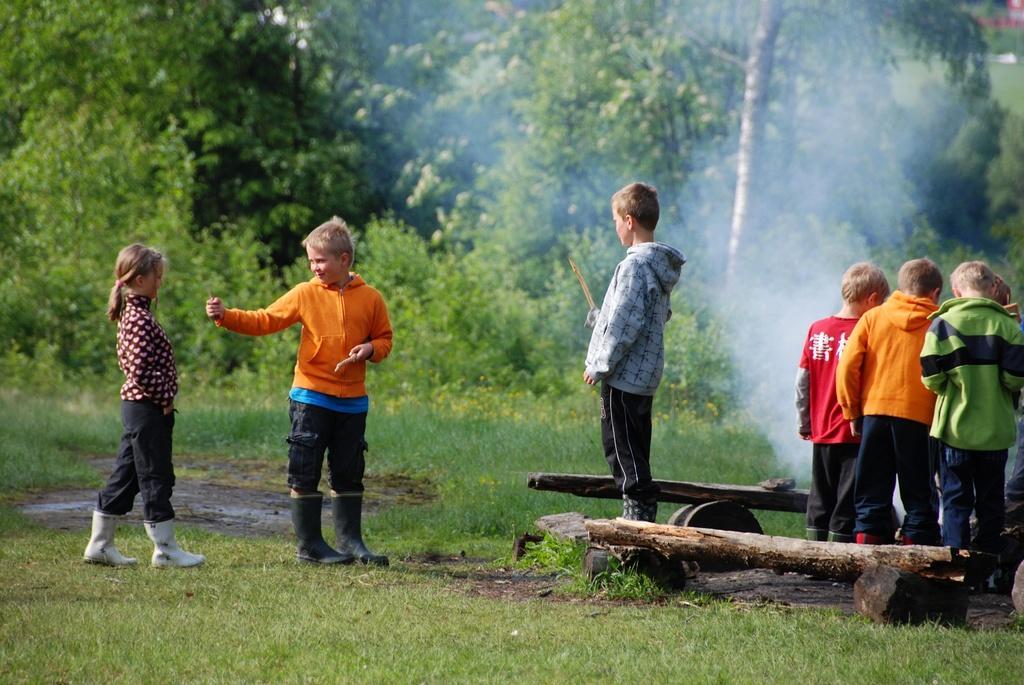Describe this image in one or two sentences. In this image there are a few people standing on the surface of the grass and there are few wooden sticks and a wooden trolley. In the background there are trees and a smoke in the air. 